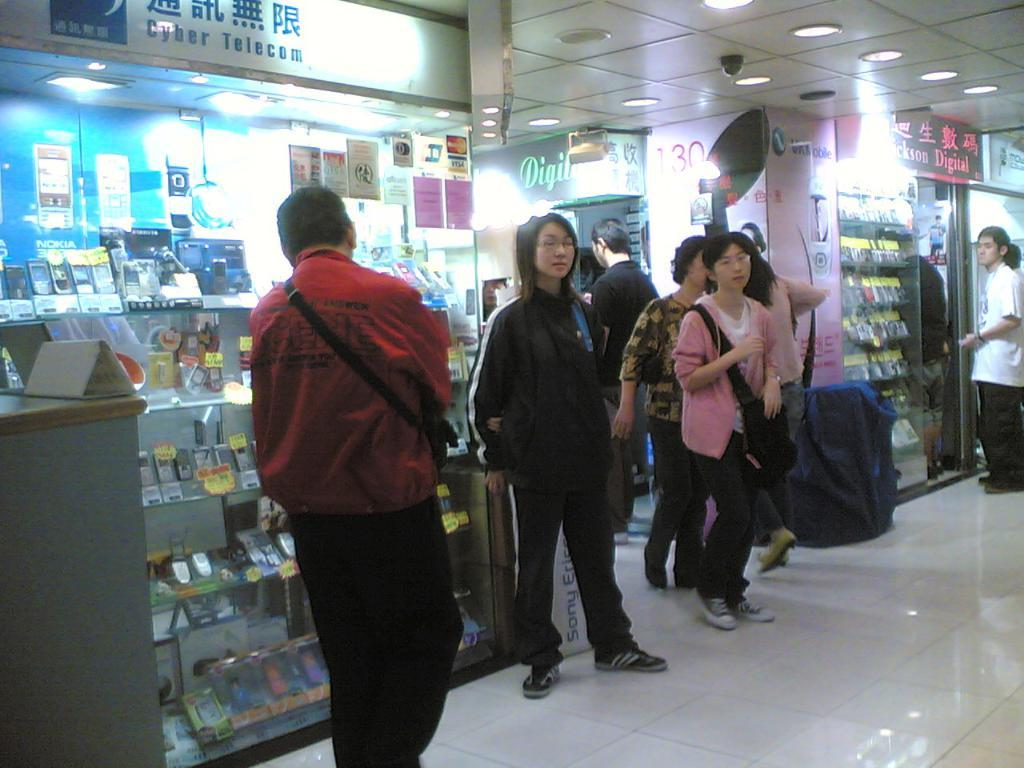What are the people in the image doing? The persons in the image are on the floor. What type of establishments can be seen in the image? There are stores in the image. the image. What objects are present in the image that are used for displaying information or advertisements? There are boards in the image. What type of electronic devices are visible in the image? There are mobiles in the image. What type of illumination is present in the image? There are lights in the image. What part of the building can be seen in the image? The ceiling is visible in the image. Can you tell me how many vases are present on the floor in the image? There is no vase present on the floor in the image. What type of hose is connected to the lights in the image? There is no hose connected to the lights in the image; the lights are likely powered by electricity. 